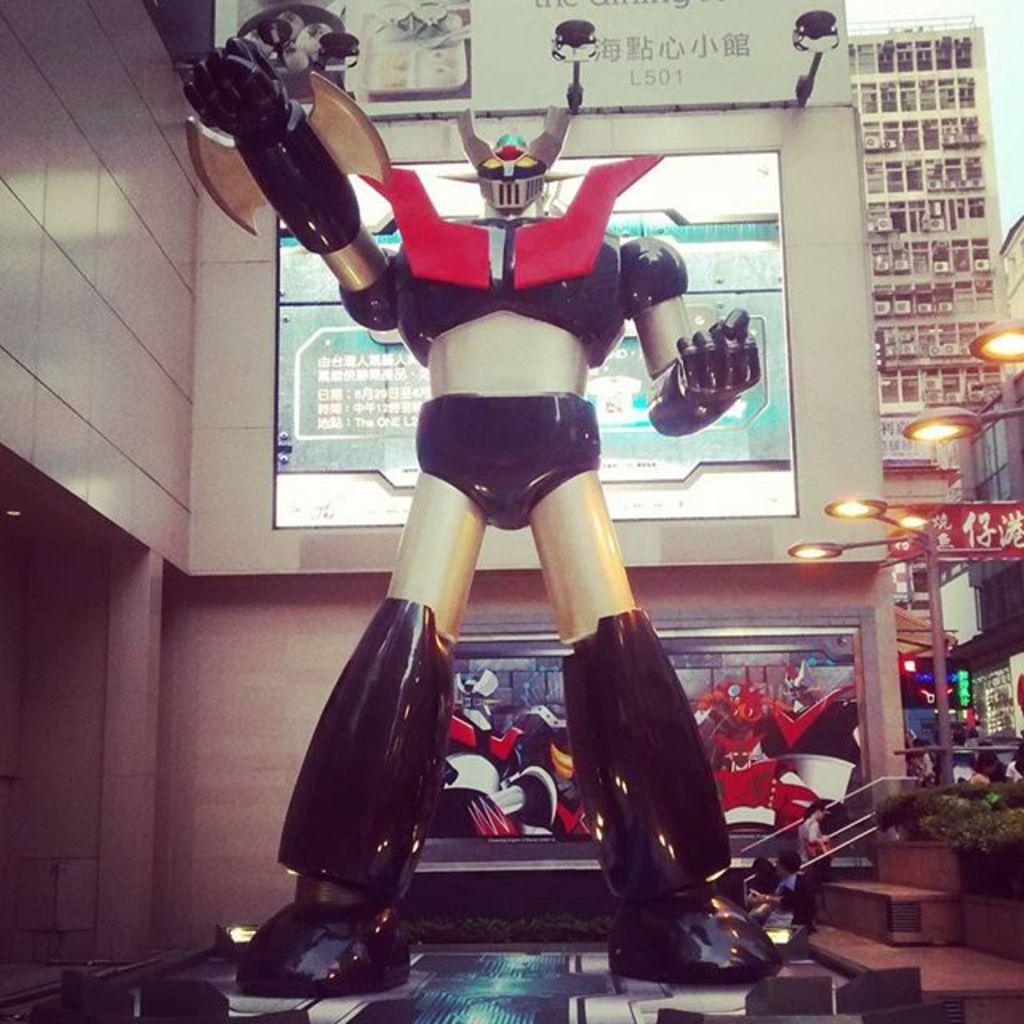Can you describe this image briefly? In this picture we can see a robot on a platform, here we can see people, plants, lights and some objects and in the background we can see a wall, screens, buildings. 